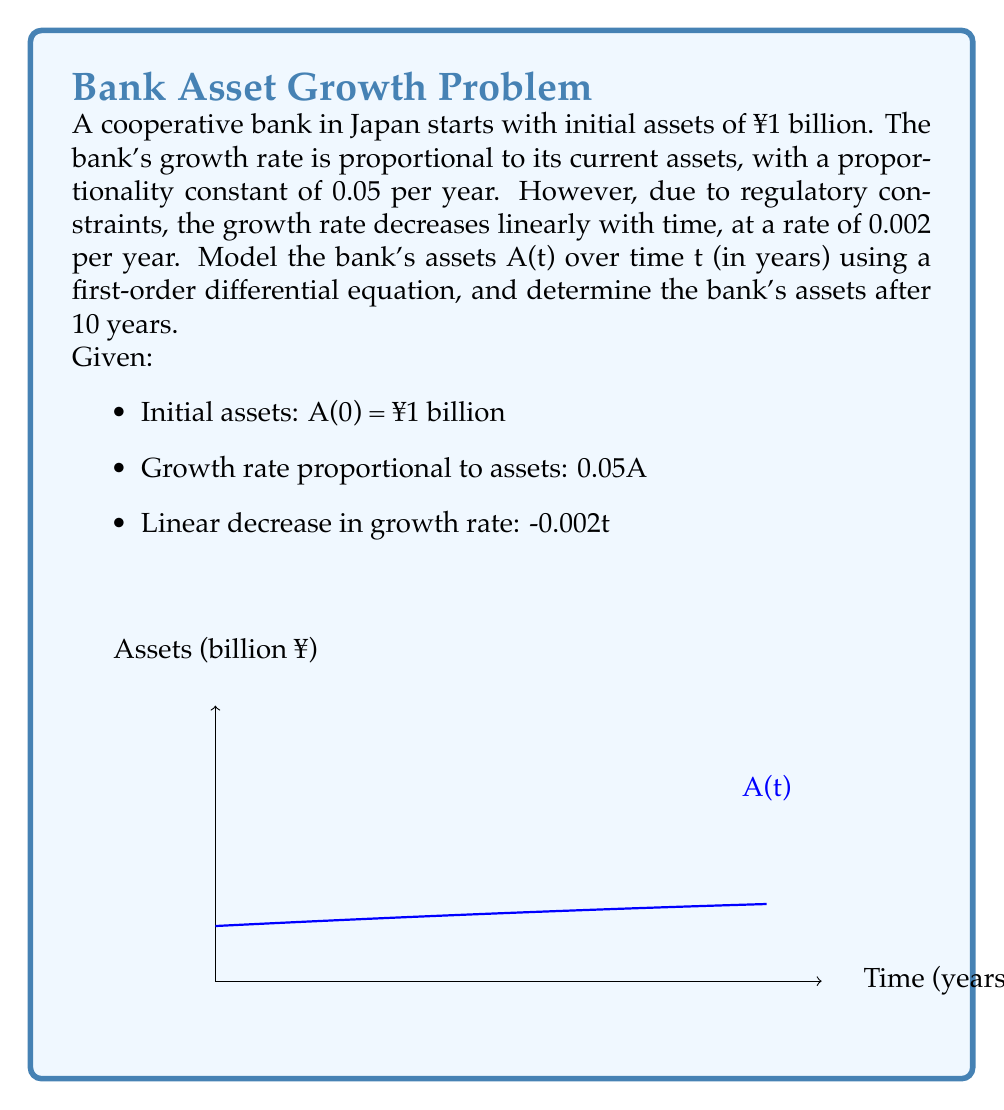Solve this math problem. 1) First, let's set up the differential equation:

   $$\frac{dA}{dt} = (0.05 - 0.002t)A$$

2) This is a first-order linear differential equation. We can solve it using the integrating factor method.

3) The integrating factor is:

   $$\mu(t) = e^{\int (0.002t - 0.05) dt} = e^{0.001t^2 - 0.05t}$$

4) Multiplying both sides of the equation by μ(t):

   $$\mu(t) \frac{dA}{dt} + \mu(t)(0.002t - 0.05)A = 0$$

5) This can be rewritten as:

   $$\frac{d}{dt}(\mu(t)A) = 0$$

6) Integrating both sides:

   $$\mu(t)A = C$$

   Where C is a constant of integration.

7) Substituting back the expression for μ(t):

   $$A(t) = Ce^{-0.001t^2 + 0.05t}$$

8) Using the initial condition A(0) = 1:

   $$1 = Ce^0 \implies C = 1$$

9) Therefore, the general solution is:

   $$A(t) = e^{-0.001t^2 + 0.05t}$$

10) To find the assets after 10 years, we evaluate A(10):

    $$A(10) = e^{-0.001(10)^2 + 0.05(10)} = e^{0.4} \approx 1.4918$$

Thus, after 10 years, the bank's assets will be approximately ¥1.4918 billion.
Answer: $A(t) = e^{-0.001t^2 + 0.05t}$; A(10) ≈ ¥1.4918 billion 